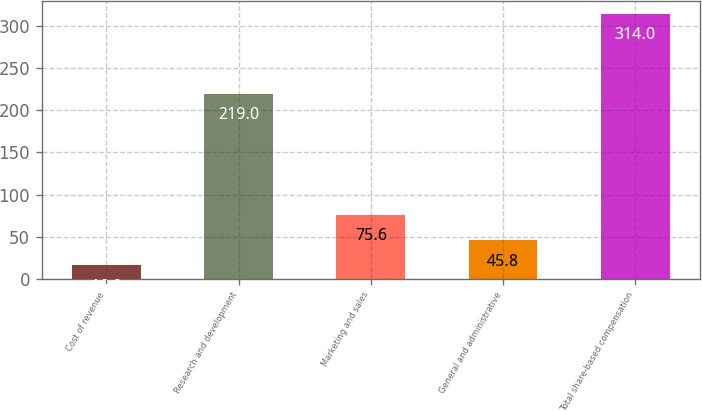<chart> <loc_0><loc_0><loc_500><loc_500><bar_chart><fcel>Cost of revenue<fcel>Research and development<fcel>Marketing and sales<fcel>General and administrative<fcel>Total share-based compensation<nl><fcel>16<fcel>219<fcel>75.6<fcel>45.8<fcel>314<nl></chart> 